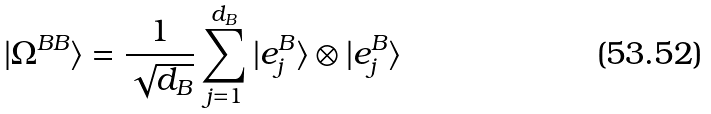Convert formula to latex. <formula><loc_0><loc_0><loc_500><loc_500>| \Omega ^ { B B } \rangle = \frac { 1 } { \sqrt { d _ { B } } } \sum _ { j = 1 } ^ { d _ { B } } | e _ { j } ^ { B } \rangle \otimes | e _ { j } ^ { B } \rangle</formula> 